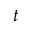<formula> <loc_0><loc_0><loc_500><loc_500>t</formula> 